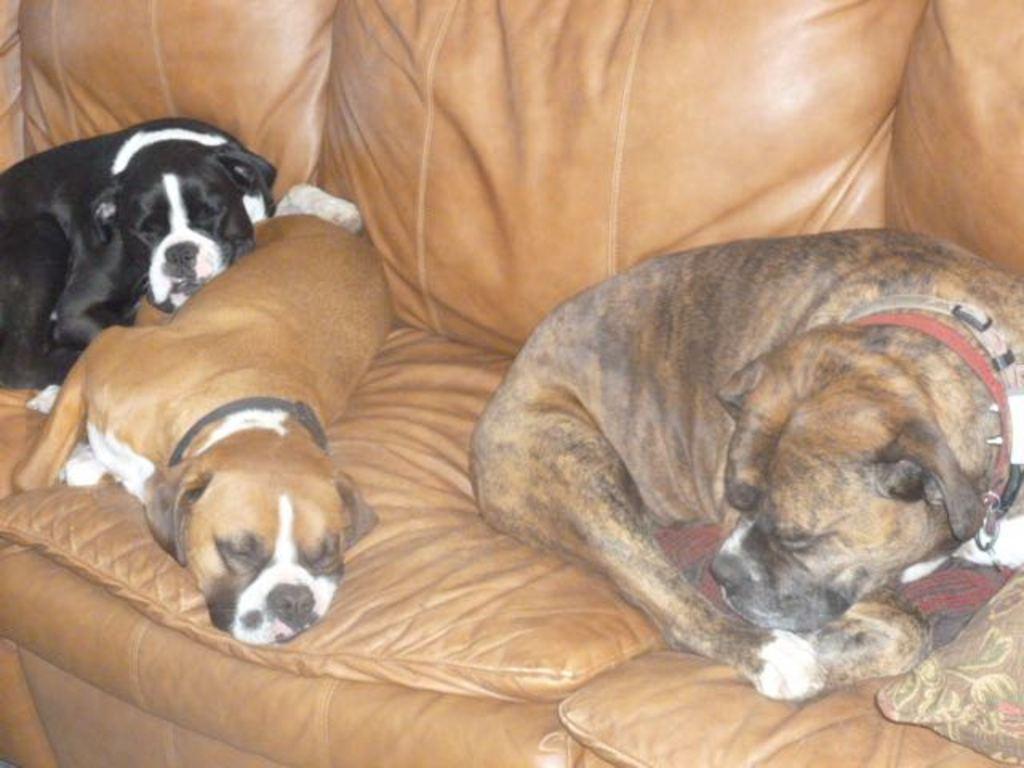Please provide a concise description of this image. In this image we can see three dogs are sleeping on a brown color sofa. We can see a pillow in the right bottom of the image. 